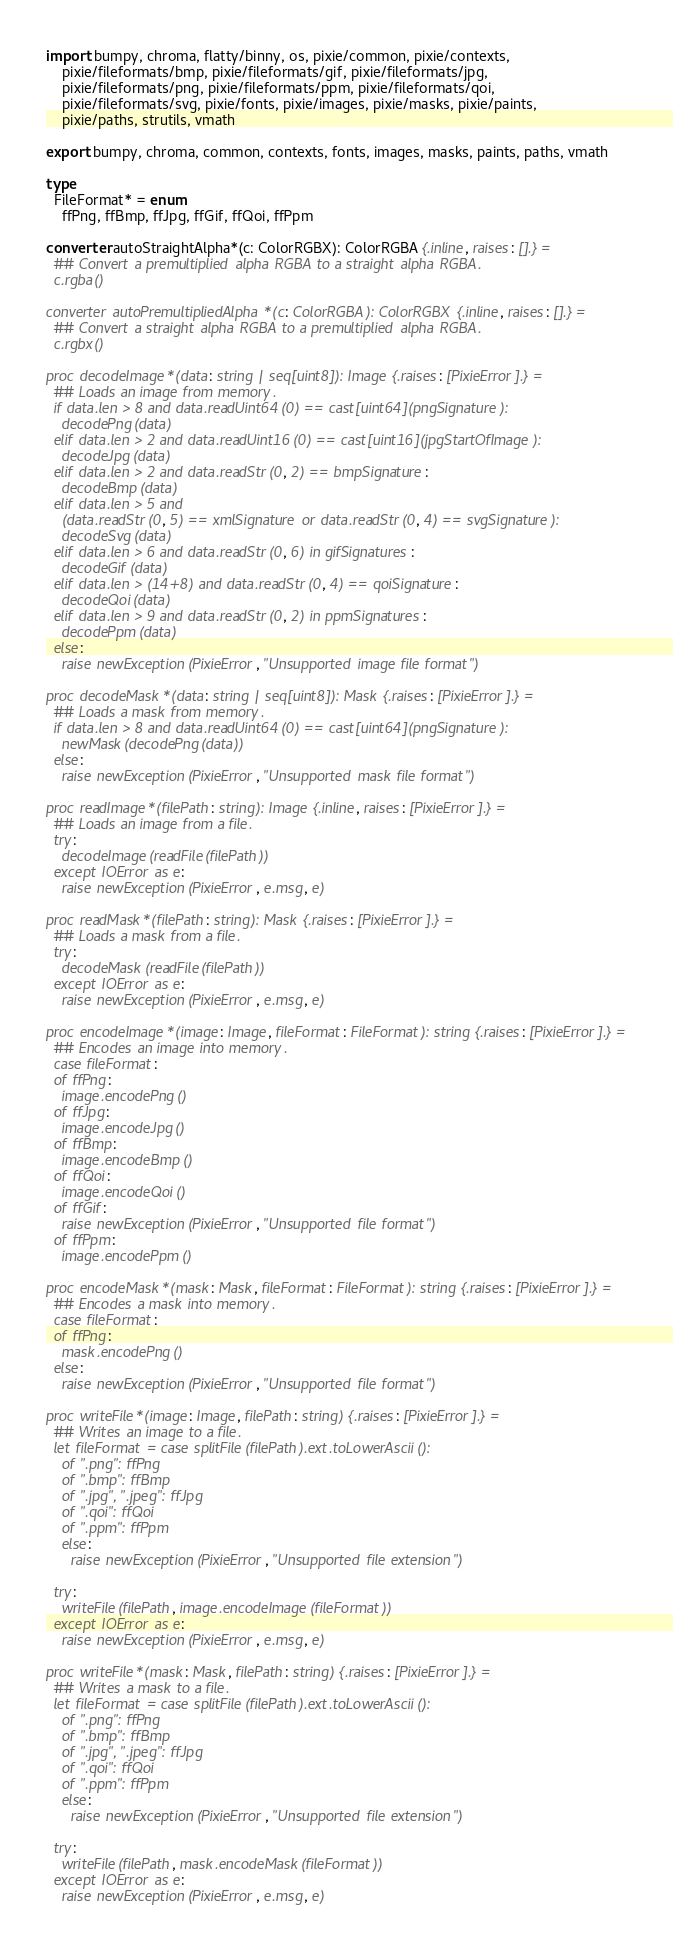Convert code to text. <code><loc_0><loc_0><loc_500><loc_500><_Nim_>import bumpy, chroma, flatty/binny, os, pixie/common, pixie/contexts,
    pixie/fileformats/bmp, pixie/fileformats/gif, pixie/fileformats/jpg,
    pixie/fileformats/png, pixie/fileformats/ppm, pixie/fileformats/qoi,
    pixie/fileformats/svg, pixie/fonts, pixie/images, pixie/masks, pixie/paints,
    pixie/paths, strutils, vmath

export bumpy, chroma, common, contexts, fonts, images, masks, paints, paths, vmath

type
  FileFormat* = enum
    ffPng, ffBmp, ffJpg, ffGif, ffQoi, ffPpm

converter autoStraightAlpha*(c: ColorRGBX): ColorRGBA {.inline, raises: [].} =
  ## Convert a premultiplied alpha RGBA to a straight alpha RGBA.
  c.rgba()

converter autoPremultipliedAlpha*(c: ColorRGBA): ColorRGBX {.inline, raises: [].} =
  ## Convert a straight alpha RGBA to a premultiplied alpha RGBA.
  c.rgbx()

proc decodeImage*(data: string | seq[uint8]): Image {.raises: [PixieError].} =
  ## Loads an image from memory.
  if data.len > 8 and data.readUint64(0) == cast[uint64](pngSignature):
    decodePng(data)
  elif data.len > 2 and data.readUint16(0) == cast[uint16](jpgStartOfImage):
    decodeJpg(data)
  elif data.len > 2 and data.readStr(0, 2) == bmpSignature:
    decodeBmp(data)
  elif data.len > 5 and
    (data.readStr(0, 5) == xmlSignature or data.readStr(0, 4) == svgSignature):
    decodeSvg(data)
  elif data.len > 6 and data.readStr(0, 6) in gifSignatures:
    decodeGif(data)
  elif data.len > (14+8) and data.readStr(0, 4) == qoiSignature:
    decodeQoi(data)
  elif data.len > 9 and data.readStr(0, 2) in ppmSignatures:
    decodePpm(data)
  else:
    raise newException(PixieError, "Unsupported image file format")

proc decodeMask*(data: string | seq[uint8]): Mask {.raises: [PixieError].} =
  ## Loads a mask from memory.
  if data.len > 8 and data.readUint64(0) == cast[uint64](pngSignature):
    newMask(decodePng(data))
  else:
    raise newException(PixieError, "Unsupported mask file format")

proc readImage*(filePath: string): Image {.inline, raises: [PixieError].} =
  ## Loads an image from a file.
  try:
    decodeImage(readFile(filePath))
  except IOError as e:
    raise newException(PixieError, e.msg, e)

proc readMask*(filePath: string): Mask {.raises: [PixieError].} =
  ## Loads a mask from a file.
  try:
    decodeMask(readFile(filePath))
  except IOError as e:
    raise newException(PixieError, e.msg, e)

proc encodeImage*(image: Image, fileFormat: FileFormat): string {.raises: [PixieError].} =
  ## Encodes an image into memory.
  case fileFormat:
  of ffPng:
    image.encodePng()
  of ffJpg:
    image.encodeJpg()
  of ffBmp:
    image.encodeBmp()
  of ffQoi:
    image.encodeQoi()
  of ffGif:
    raise newException(PixieError, "Unsupported file format")
  of ffPpm:
    image.encodePpm()

proc encodeMask*(mask: Mask, fileFormat: FileFormat): string {.raises: [PixieError].} =
  ## Encodes a mask into memory.
  case fileFormat:
  of ffPng:
    mask.encodePng()
  else:
    raise newException(PixieError, "Unsupported file format")

proc writeFile*(image: Image, filePath: string) {.raises: [PixieError].} =
  ## Writes an image to a file.
  let fileFormat = case splitFile(filePath).ext.toLowerAscii():
    of ".png": ffPng
    of ".bmp": ffBmp
    of ".jpg", ".jpeg": ffJpg
    of ".qoi": ffQoi
    of ".ppm": ffPpm
    else:
      raise newException(PixieError, "Unsupported file extension")

  try:
    writeFile(filePath, image.encodeImage(fileFormat))
  except IOError as e:
    raise newException(PixieError, e.msg, e)

proc writeFile*(mask: Mask, filePath: string) {.raises: [PixieError].} =
  ## Writes a mask to a file.
  let fileFormat = case splitFile(filePath).ext.toLowerAscii():
    of ".png": ffPng
    of ".bmp": ffBmp
    of ".jpg", ".jpeg": ffJpg
    of ".qoi": ffQoi
    of ".ppm": ffPpm
    else:
      raise newException(PixieError, "Unsupported file extension")

  try:
    writeFile(filePath, mask.encodeMask(fileFormat))
  except IOError as e:
    raise newException(PixieError, e.msg, e)
</code> 